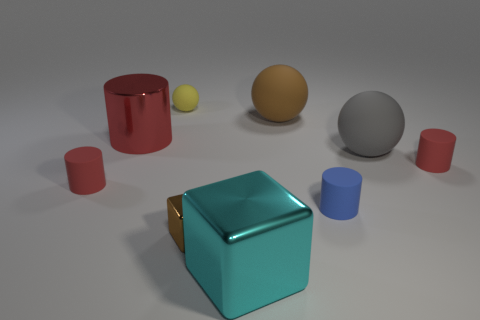What number of metallic objects are both right of the tiny brown cube and behind the brown metal block?
Your response must be concise. 0. What is the material of the yellow thing that is the same size as the blue thing?
Your answer should be compact. Rubber. There is a cube that is left of the large cyan metallic block; is it the same size as the thing in front of the small shiny cube?
Your answer should be compact. No. Are there any red cylinders to the left of the yellow object?
Provide a succinct answer. Yes. There is a tiny thing that is on the right side of the rubber ball that is right of the large brown thing; what is its color?
Your answer should be very brief. Red. Is the number of big metal cubes less than the number of small red matte things?
Offer a terse response. Yes. What number of other objects have the same shape as the small brown thing?
Your response must be concise. 1. The metallic cube that is the same size as the red shiny cylinder is what color?
Your response must be concise. Cyan. Are there the same number of big brown spheres that are on the left side of the red shiny cylinder and tiny red cylinders that are right of the big cyan cube?
Keep it short and to the point. No. Is there a gray ball of the same size as the brown metal object?
Provide a succinct answer. No. 